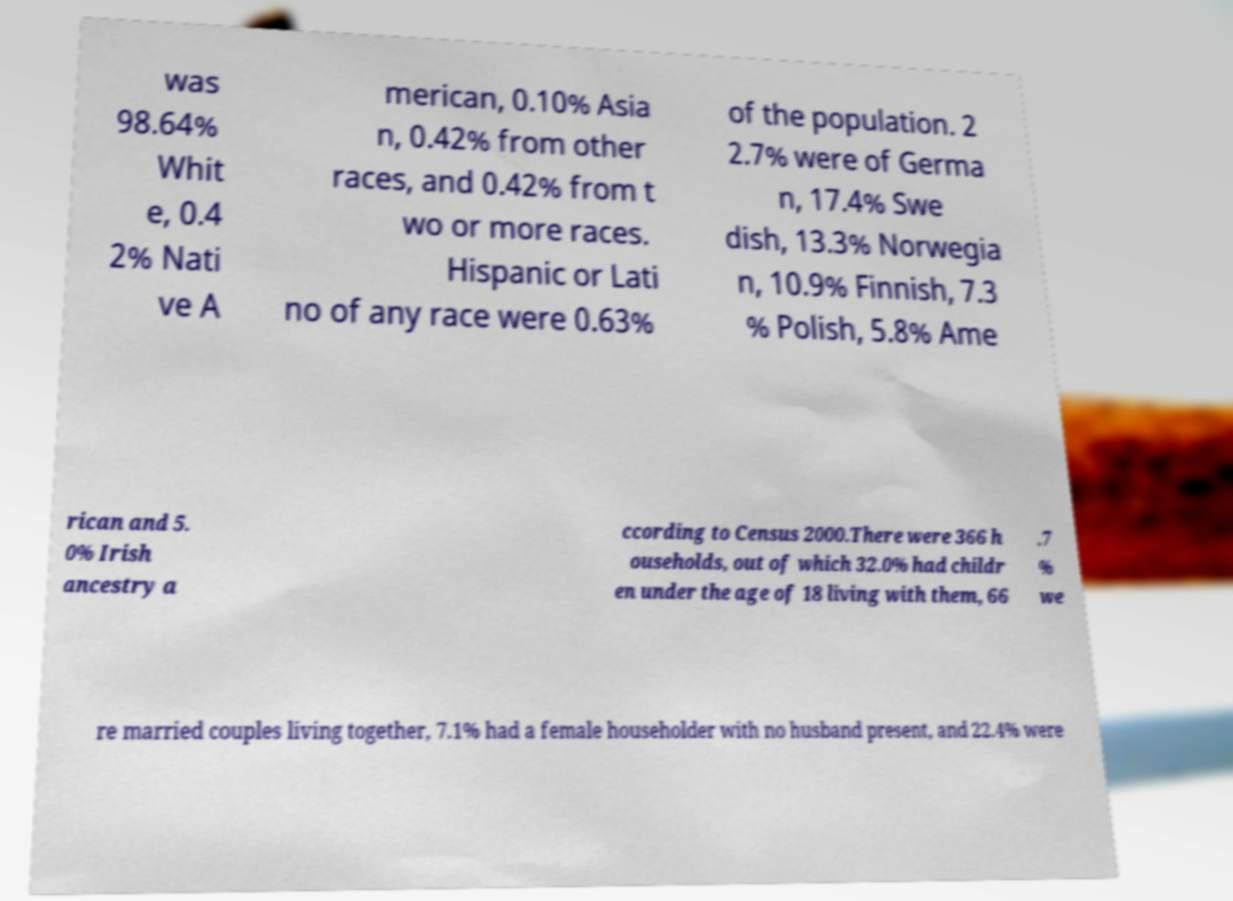I need the written content from this picture converted into text. Can you do that? was 98.64% Whit e, 0.4 2% Nati ve A merican, 0.10% Asia n, 0.42% from other races, and 0.42% from t wo or more races. Hispanic or Lati no of any race were 0.63% of the population. 2 2.7% were of Germa n, 17.4% Swe dish, 13.3% Norwegia n, 10.9% Finnish, 7.3 % Polish, 5.8% Ame rican and 5. 0% Irish ancestry a ccording to Census 2000.There were 366 h ouseholds, out of which 32.0% had childr en under the age of 18 living with them, 66 .7 % we re married couples living together, 7.1% had a female householder with no husband present, and 22.4% were 